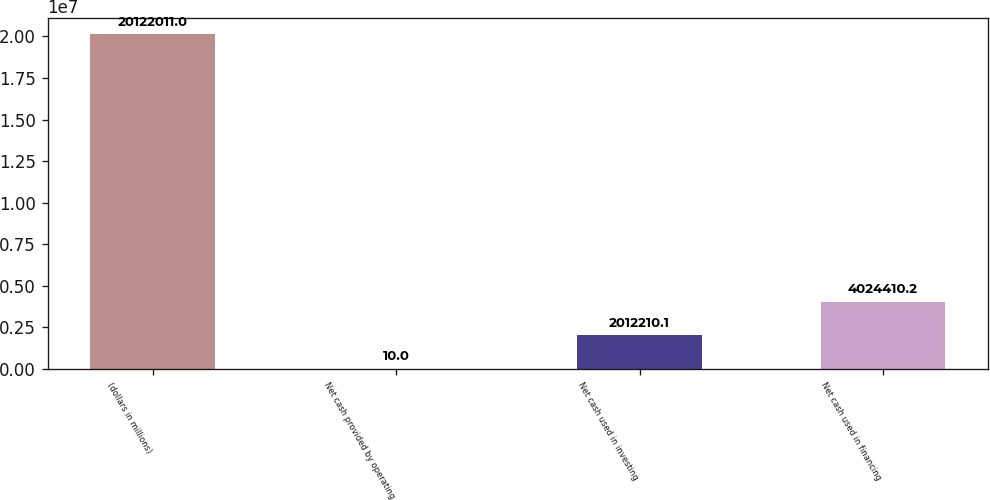<chart> <loc_0><loc_0><loc_500><loc_500><bar_chart><fcel>(dollars in millions)<fcel>Net cash provided by operating<fcel>Net cash used in investing<fcel>Net cash used in financing<nl><fcel>2.0122e+07<fcel>10<fcel>2.01221e+06<fcel>4.02441e+06<nl></chart> 